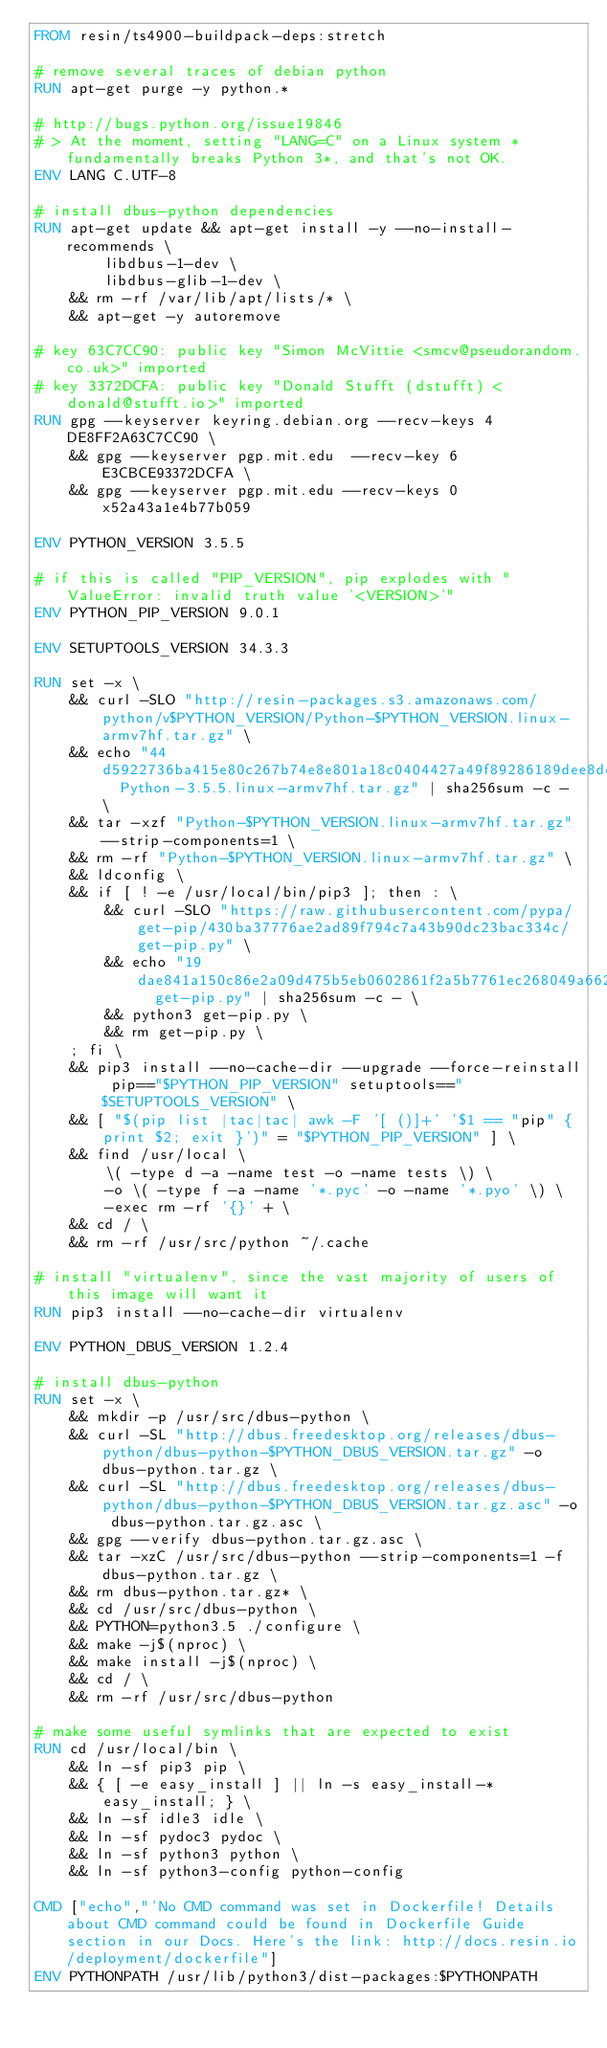Convert code to text. <code><loc_0><loc_0><loc_500><loc_500><_Dockerfile_>FROM resin/ts4900-buildpack-deps:stretch

# remove several traces of debian python
RUN apt-get purge -y python.*

# http://bugs.python.org/issue19846
# > At the moment, setting "LANG=C" on a Linux system *fundamentally breaks Python 3*, and that's not OK.
ENV LANG C.UTF-8

# install dbus-python dependencies 
RUN apt-get update && apt-get install -y --no-install-recommends \
		libdbus-1-dev \
		libdbus-glib-1-dev \
	&& rm -rf /var/lib/apt/lists/* \
	&& apt-get -y autoremove

# key 63C7CC90: public key "Simon McVittie <smcv@pseudorandom.co.uk>" imported
# key 3372DCFA: public key "Donald Stufft (dstufft) <donald@stufft.io>" imported
RUN gpg --keyserver keyring.debian.org --recv-keys 4DE8FF2A63C7CC90 \
	&& gpg --keyserver pgp.mit.edu  --recv-key 6E3CBCE93372DCFA \
	&& gpg --keyserver pgp.mit.edu --recv-keys 0x52a43a1e4b77b059

ENV PYTHON_VERSION 3.5.5

# if this is called "PIP_VERSION", pip explodes with "ValueError: invalid truth value '<VERSION>'"
ENV PYTHON_PIP_VERSION 9.0.1

ENV SETUPTOOLS_VERSION 34.3.3

RUN set -x \
	&& curl -SLO "http://resin-packages.s3.amazonaws.com/python/v$PYTHON_VERSION/Python-$PYTHON_VERSION.linux-armv7hf.tar.gz" \
	&& echo "44d5922736ba415e80c267b74e8e801a18c0404427a49f89286189dee8dee293  Python-3.5.5.linux-armv7hf.tar.gz" | sha256sum -c - \
	&& tar -xzf "Python-$PYTHON_VERSION.linux-armv7hf.tar.gz" --strip-components=1 \
	&& rm -rf "Python-$PYTHON_VERSION.linux-armv7hf.tar.gz" \
	&& ldconfig \
	&& if [ ! -e /usr/local/bin/pip3 ]; then : \
		&& curl -SLO "https://raw.githubusercontent.com/pypa/get-pip/430ba37776ae2ad89f794c7a43b90dc23bac334c/get-pip.py" \
		&& echo "19dae841a150c86e2a09d475b5eb0602861f2a5b7761ec268049a662dbd2bd0c  get-pip.py" | sha256sum -c - \
		&& python3 get-pip.py \
		&& rm get-pip.py \
	; fi \
	&& pip3 install --no-cache-dir --upgrade --force-reinstall pip=="$PYTHON_PIP_VERSION" setuptools=="$SETUPTOOLS_VERSION" \
	&& [ "$(pip list |tac|tac| awk -F '[ ()]+' '$1 == "pip" { print $2; exit }')" = "$PYTHON_PIP_VERSION" ] \
	&& find /usr/local \
		\( -type d -a -name test -o -name tests \) \
		-o \( -type f -a -name '*.pyc' -o -name '*.pyo' \) \
		-exec rm -rf '{}' + \
	&& cd / \
	&& rm -rf /usr/src/python ~/.cache

# install "virtualenv", since the vast majority of users of this image will want it
RUN pip3 install --no-cache-dir virtualenv

ENV PYTHON_DBUS_VERSION 1.2.4

# install dbus-python
RUN set -x \
	&& mkdir -p /usr/src/dbus-python \
	&& curl -SL "http://dbus.freedesktop.org/releases/dbus-python/dbus-python-$PYTHON_DBUS_VERSION.tar.gz" -o dbus-python.tar.gz \
	&& curl -SL "http://dbus.freedesktop.org/releases/dbus-python/dbus-python-$PYTHON_DBUS_VERSION.tar.gz.asc" -o dbus-python.tar.gz.asc \
	&& gpg --verify dbus-python.tar.gz.asc \
	&& tar -xzC /usr/src/dbus-python --strip-components=1 -f dbus-python.tar.gz \
	&& rm dbus-python.tar.gz* \
	&& cd /usr/src/dbus-python \
	&& PYTHON=python3.5 ./configure \
	&& make -j$(nproc) \
	&& make install -j$(nproc) \
	&& cd / \
	&& rm -rf /usr/src/dbus-python

# make some useful symlinks that are expected to exist
RUN cd /usr/local/bin \
	&& ln -sf pip3 pip \
	&& { [ -e easy_install ] || ln -s easy_install-* easy_install; } \
	&& ln -sf idle3 idle \
	&& ln -sf pydoc3 pydoc \
	&& ln -sf python3 python \
	&& ln -sf python3-config python-config

CMD ["echo","'No CMD command was set in Dockerfile! Details about CMD command could be found in Dockerfile Guide section in our Docs. Here's the link: http://docs.resin.io/deployment/dockerfile"]
ENV PYTHONPATH /usr/lib/python3/dist-packages:$PYTHONPATH
</code> 